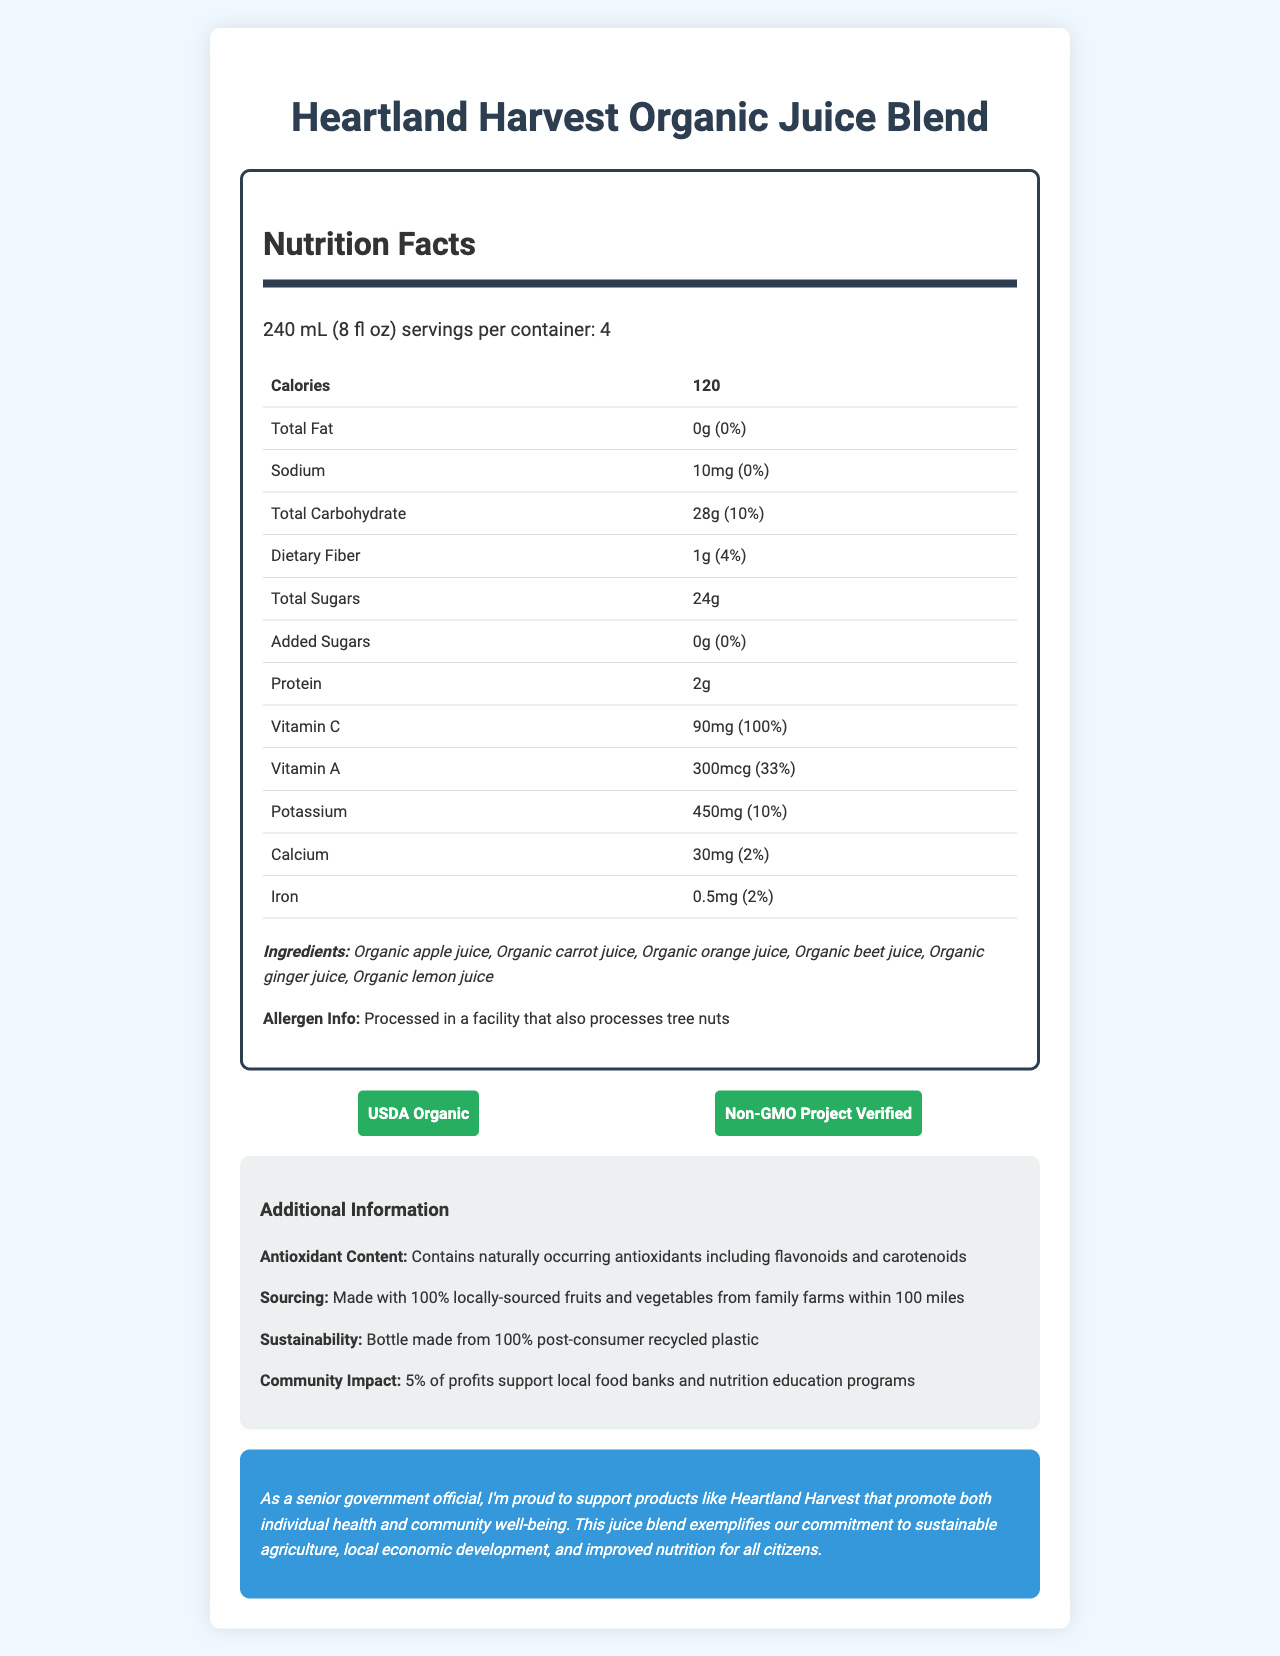What is the serving size for Heartland Harvest Organic Juice Blend? The serving size is stated directly under the product name and nutrition facts section.
Answer: 240 mL (8 fl oz) How many servings are there per container? This information is found in the nutrition facts section under the serving size information.
Answer: 4 How many calories are in one serving? The calorie content per serving is explicitly stated in the nutrition facts section.
Answer: 120 How much total fat is in one serving? The total fat content per serving is provided in the nutrition facts section.
Answer: 0g What is the vitamin C content per serving, and what is its daily value percentage? The amount and daily value percentage of vitamin C are listed in the nutrition facts section.
Answer: 90mg, 100% What allergens should consumers be aware of? The allergen information is listed towards the end of the nutrition facts section.
Answer: Processed in a facility that also processes tree nuts What are the main ingredients of this juice blend? A. Organic apple juice, Organic orange juice, Organic lemon juice B. Organic apple juice, Organic carrot juice, Organic ginger juice C. Organic beet juice, Organic ginger juice, Organic carrot juice The main ingredients are listed in the ingredients section of the nutrition facts.
Answer: B. Organic apple juice, Organic carrot juice, Organic ginger juice What certifications does the Heartland Harvest Organic Juice Blend have? A. USDA Organic B. Non-GMO Project Verified C. Fair Trade Certified D. Both A and B The certifications are highlighted in the certifications section with badges.
Answer: D. Both A and B Is there any added sugar in Heartland Harvest Organic Juice Blend? The nutrition facts section shows "Added Sugars: 0g (0%)".
Answer: No Does the document mention the source of the fruits and vegetables used in the juice blend? The additional information section states that the fruits and vegetables are 100% locally-sourced from family farms within 100 miles.
Answer: Yes Summarize the main points of the document. The document primarily focuses on nutritional information, ingredient sourcing, antioxidant content, and community impact, concluding with a governmental endorsement.
Answer: The document provides the nutrition facts for Heartland Harvest Organic Juice Blend. It emphasizes the high vitamin C and antioxidant content, mentions the organic and non-GMO certifications, lists the locally-sourced ingredients, and highlights the product's impact on sustainability and community support. Additionally, it includes a government statement supporting the product's health and economic benefits. What community initiatives does the Heartland Harvest Organic Juice Blend support? This information is provided in the additional information section.
Answer: 5% of profits support local food banks and nutrition education programs Which micronutrient has the highest daily value percentage per serving? A. Vitamin A B. Calcium C. Iron D. Vitamin C The daily value percentage of vitamin C is the highest at 100%, which can be found in the nutrition facts table.
Answer: D. Vitamin C Can I determine if the product contains artificial flavors? The document does not provide specific information about artificial flavors being included or excluded.
Answer: Not enough information What is the sodium content per serving, and what is its daily value percentage? This information is found in the nutrition facts section under sodium content.
Answer: 10mg, 0% 